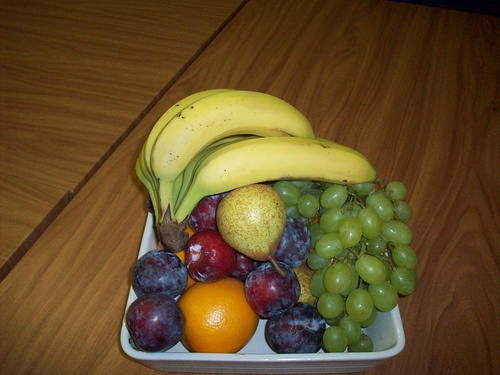Describe the objects in this image and their specific colors. I can see dining table in black, maroon, and olive tones, bowl in black, darkgreen, gray, and maroon tones, banana in black, khaki, and olive tones, apple in black, gray, and maroon tones, and orange in black, red, orange, and maroon tones in this image. 